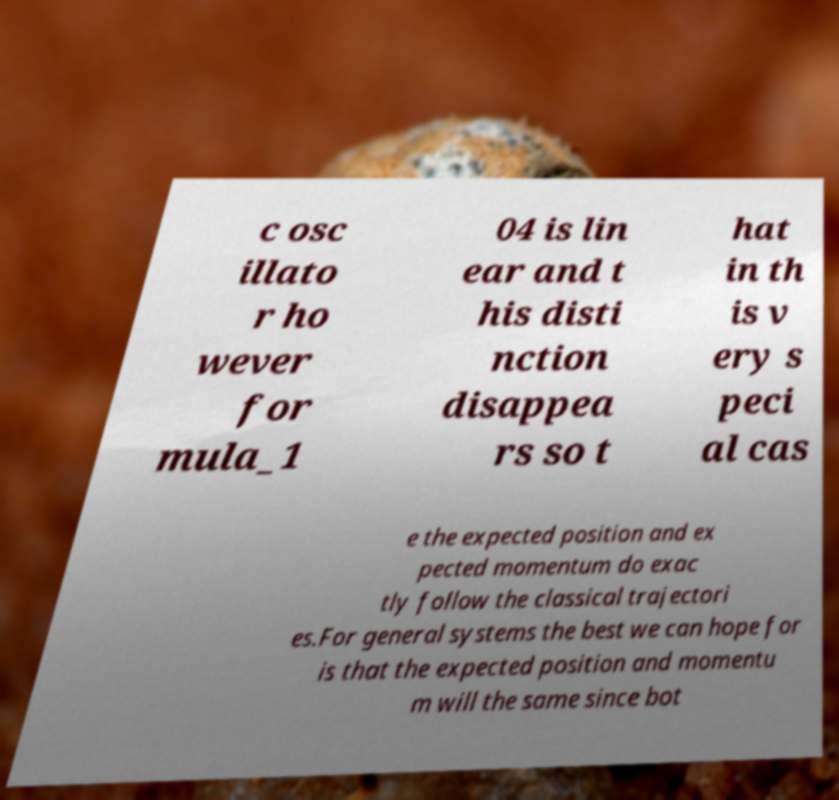Please identify and transcribe the text found in this image. c osc illato r ho wever for mula_1 04 is lin ear and t his disti nction disappea rs so t hat in th is v ery s peci al cas e the expected position and ex pected momentum do exac tly follow the classical trajectori es.For general systems the best we can hope for is that the expected position and momentu m will the same since bot 